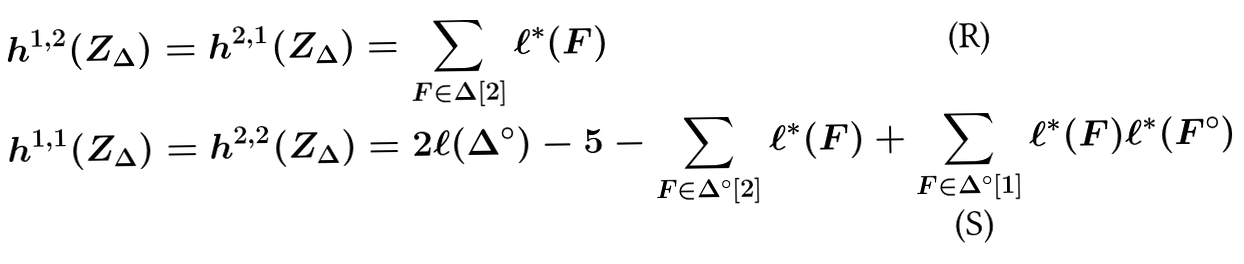Convert formula to latex. <formula><loc_0><loc_0><loc_500><loc_500>h ^ { 1 , 2 } ( Z _ { \Delta } ) = h ^ { 2 , 1 } ( Z _ { \Delta } ) & = \sum _ { F \in \Delta [ 2 ] } \ell ^ { * } ( F ) \\ h ^ { 1 , 1 } ( Z _ { \Delta } ) = h ^ { 2 , 2 } ( Z _ { \Delta } ) & = 2 \ell ( \Delta ^ { \circ } ) - 5 - \sum _ { F \in \Delta ^ { \circ } [ 2 ] } \ell ^ { * } ( F ) + \sum _ { F \in \Delta ^ { \circ } [ 1 ] } \ell ^ { * } ( F ) \ell ^ { * } ( F ^ { \circ } )</formula> 